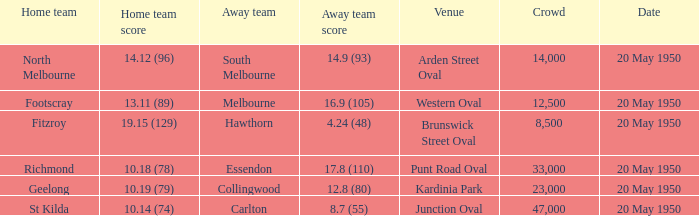Could you parse the entire table as a dict? {'header': ['Home team', 'Home team score', 'Away team', 'Away team score', 'Venue', 'Crowd', 'Date'], 'rows': [['North Melbourne', '14.12 (96)', 'South Melbourne', '14.9 (93)', 'Arden Street Oval', '14,000', '20 May 1950'], ['Footscray', '13.11 (89)', 'Melbourne', '16.9 (105)', 'Western Oval', '12,500', '20 May 1950'], ['Fitzroy', '19.15 (129)', 'Hawthorn', '4.24 (48)', 'Brunswick Street Oval', '8,500', '20 May 1950'], ['Richmond', '10.18 (78)', 'Essendon', '17.8 (110)', 'Punt Road Oval', '33,000', '20 May 1950'], ['Geelong', '10.19 (79)', 'Collingwood', '12.8 (80)', 'Kardinia Park', '23,000', '20 May 1950'], ['St Kilda', '10.14 (74)', 'Carlton', '8.7 (55)', 'Junction Oval', '47,000', '20 May 1950']]} What was the largest crowd to view a game where the away team scored 17.8 (110)? 33000.0. 